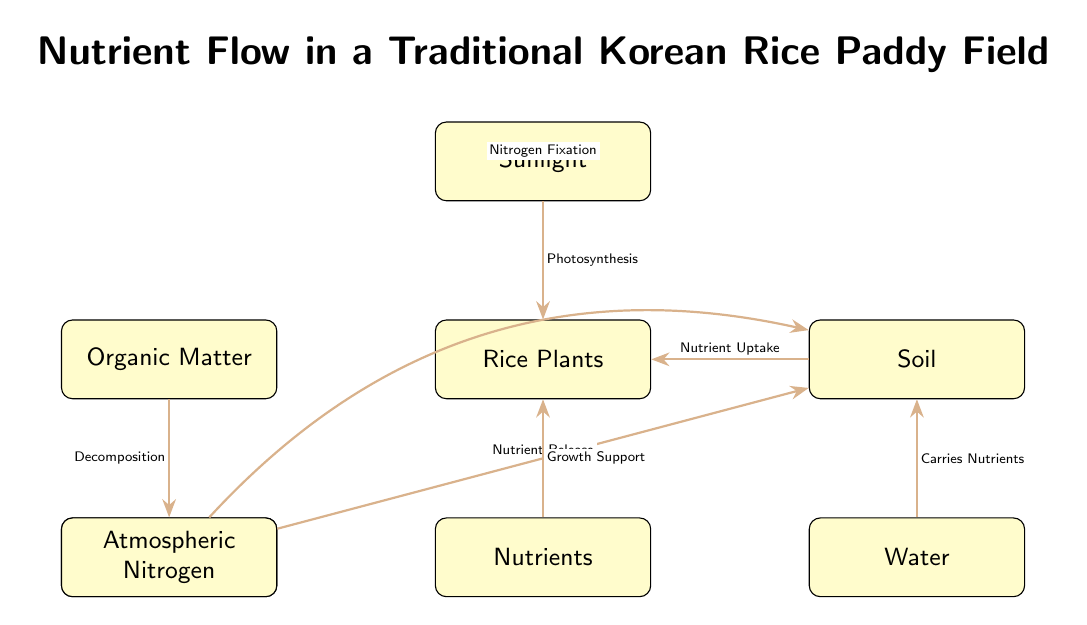What is the title of the diagram? The title of the diagram can be found at the top of the visual representation. It describes the overall focus of the diagram, which is nutrient flow.
Answer: Nutrient Flow in a Traditional Korean Rice Paddy Field How many nodes are in the diagram? To determine the number of nodes, I will count all distinct components represented, which include sunlight, rice plants, organic matter, soil, microorganisms, water, nutrients, and atmospheric nitrogen. There are a total of 8 nodes.
Answer: 8 What relationship connects sunlight and rice plants? The relationship connecting sunlight and rice plants is indicated by an arrow labeled "Photosynthesis," which shows how sunlight contributes to rice growth.
Answer: Photosynthesis Which node represents the source of atmospheric nitrogen? The node showing the source of atmospheric nitrogen is labeled "Atmospheric Nitrogen." It contributes directly to soil through the process of nitrogen fixation.
Answer: Atmospheric Nitrogen What process occurs between microorganisms and organic matter? The process occurring between microorganisms and organic matter, as indicated in the diagram by an arrow, is "Decomposition," which signifies how microorganisms break down organic matter.
Answer: Decomposition Which component carries nutrients to soil? The component that carries nutrients to the soil is water. This relationship is demonstrated in the diagram with an arrow that indicates water's role in nutrient transportation.
Answer: Water How do nutrients support rice plants? Nutrients support rice plants through the relationship labeled "Growth Support," showing that nutrients are essential for the plant's development.
Answer: Growth Support What connects soil to rice plants? The connection from soil to rice plants is indicated by the arrow labeled "Nutrient Uptake," which illustrates the process through which rice plants absorb nutrients from the soil.
Answer: Nutrient Uptake What process brings nitrogen from the atmosphere to the soil? The process indicated in the diagram for bringing nitrogen from the atmosphere to the soil is "Nitrogen Fixation," described by the arrow bending from atmospheric nitrogen to soil.
Answer: Nitrogen Fixation 